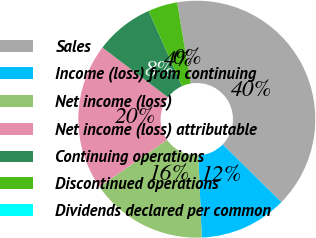<chart> <loc_0><loc_0><loc_500><loc_500><pie_chart><fcel>Sales<fcel>Income (loss) from continuing<fcel>Net income (loss)<fcel>Net income (loss) attributable<fcel>Continuing operations<fcel>Discontinued operations<fcel>Dividends declared per common<nl><fcel>39.99%<fcel>12.0%<fcel>16.0%<fcel>20.0%<fcel>8.0%<fcel>4.0%<fcel>0.0%<nl></chart> 